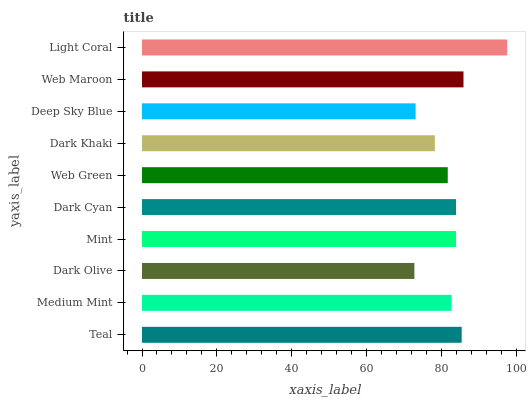Is Dark Olive the minimum?
Answer yes or no. Yes. Is Light Coral the maximum?
Answer yes or no. Yes. Is Medium Mint the minimum?
Answer yes or no. No. Is Medium Mint the maximum?
Answer yes or no. No. Is Teal greater than Medium Mint?
Answer yes or no. Yes. Is Medium Mint less than Teal?
Answer yes or no. Yes. Is Medium Mint greater than Teal?
Answer yes or no. No. Is Teal less than Medium Mint?
Answer yes or no. No. Is Dark Cyan the high median?
Answer yes or no. Yes. Is Medium Mint the low median?
Answer yes or no. Yes. Is Web Maroon the high median?
Answer yes or no. No. Is Dark Khaki the low median?
Answer yes or no. No. 